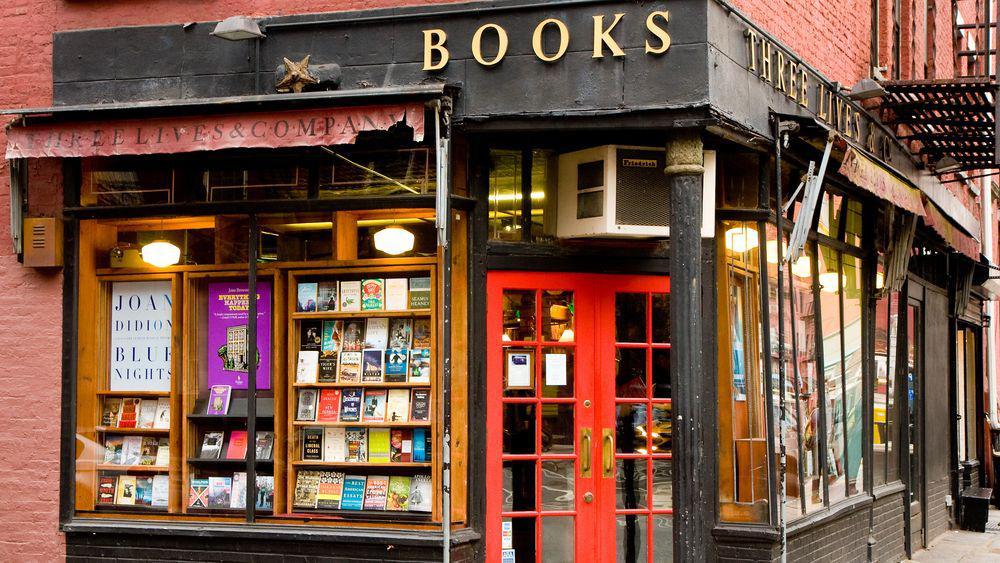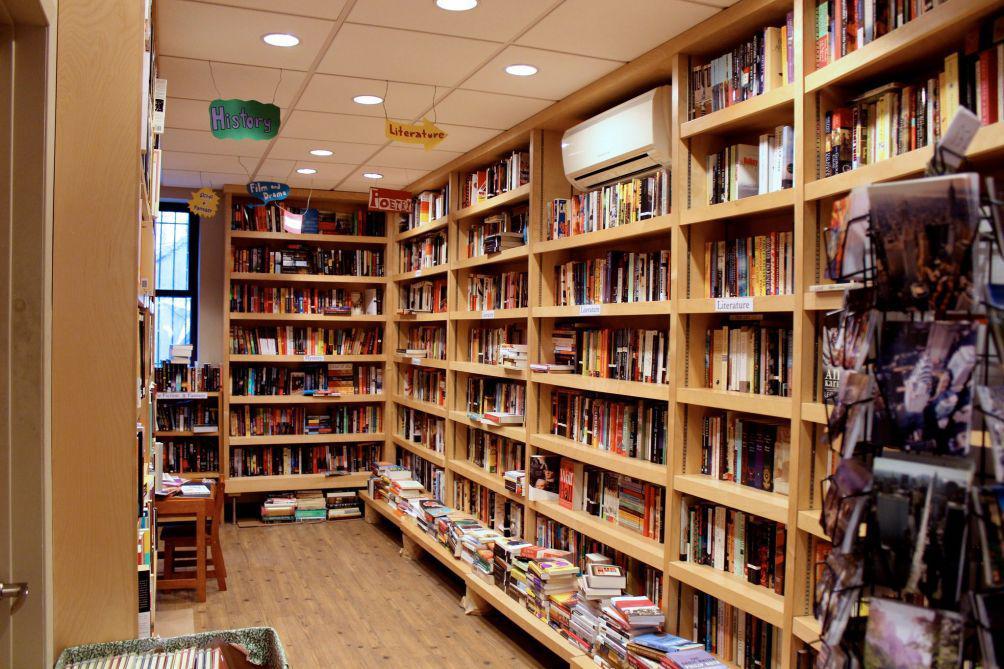The first image is the image on the left, the second image is the image on the right. Analyze the images presented: Is the assertion "In one of the image a red door is open." valid? Answer yes or no. No. The first image is the image on the left, the second image is the image on the right. Analyze the images presented: Is the assertion "The store in the right image has a red door with multiple windows built into the door." valid? Answer yes or no. No. 